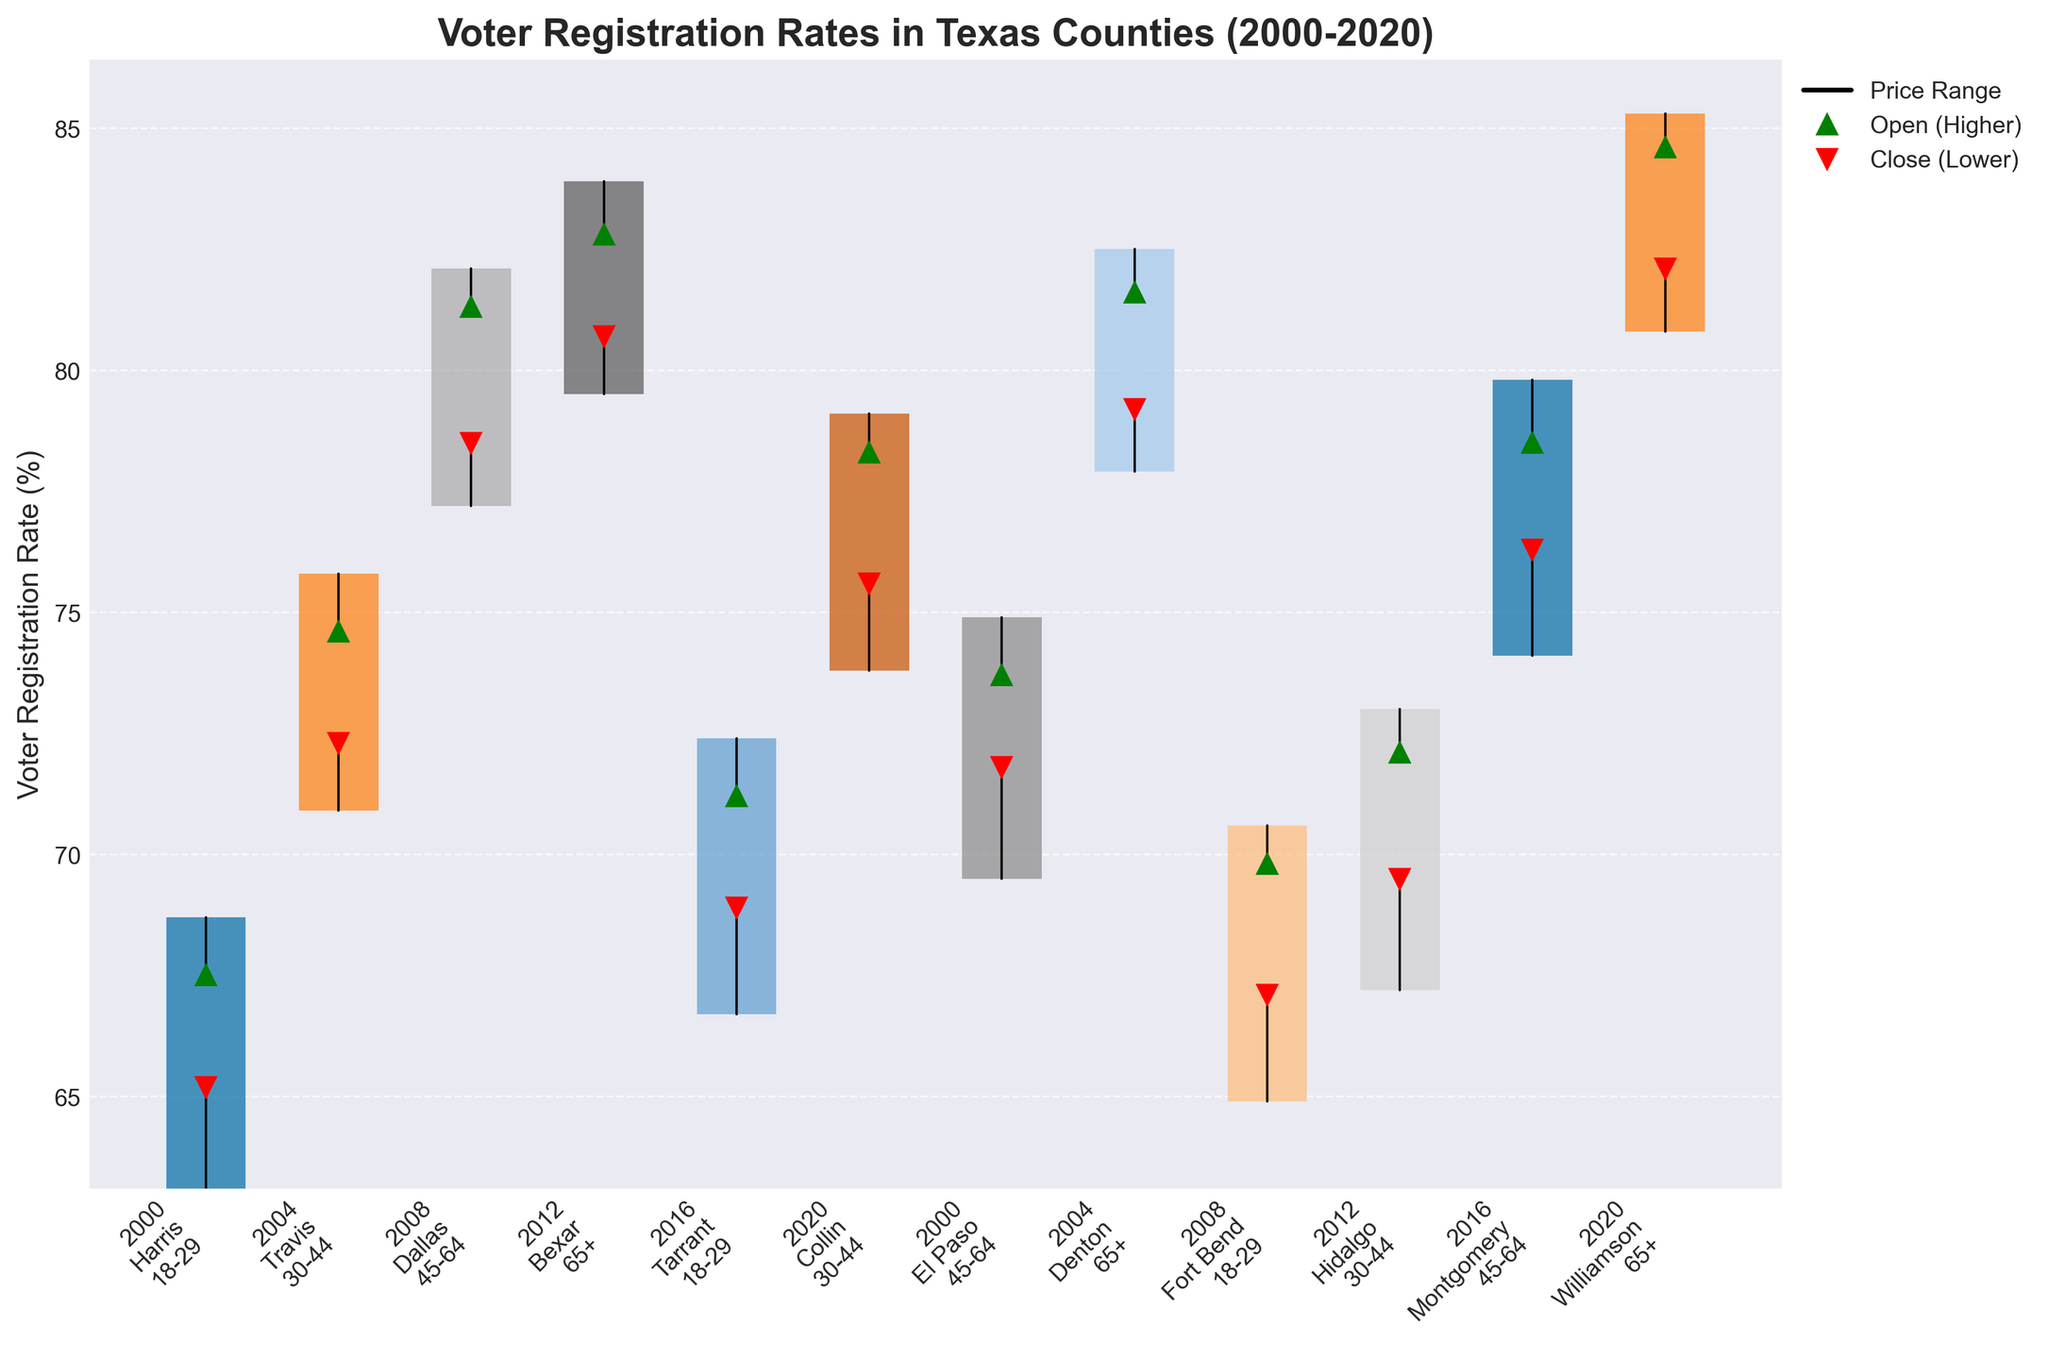What's the title of the figure? The title of the figure is prominently displayed at the top.
Answer: Voter Registration Rates in Texas Counties (2000-2020) How many distinct age groups are represented in the figure? The age groups are listed in each bar label. Counting the unique groups: "18-29", "30-44", "45-64", "65+".
Answer: 4 Which county had the highest voter registration rate in 2020 for the age group 65+? Locate the bar labeled "2020 Williamson 65+" and identify its highest value.
Answer: Williamson Which age group shows the greatest increase in voter registration rate between Open and Close values in Harris County in 2000? Examine the bar labeled "2000 Harris 18-29". The increase is the difference between Open (65.2) and Close (67.5).
Answer: 2.3% Was the voter registration rate higher at the close or open in Tarrant County in 2016 for the age group 18-29? Look for the markers on the bar labeled "2016 Tarrant 18-29". The open marker (red) is at 68.9, and the close marker (green) is at 71.2.
Answer: Close Compare the voter registration rate range (High-Low) for Dallas County in 2008 and Montgomery County in 2016 for age groups 45-64. Which one is higher? For "2008 Dallas", the range is 82.1 - 77.2 = 4.9. For "2016 Montgomery", the range is 79.8 - 74.1 = 5.7.
Answer: Montgomery County In which county and age group did the voter registration rate decrease from open to close value in 2000? Review the bars labeled "2000" and look for those where the red marker (down triangle) is above the green marker (up triangle). It's "2000 El Paso 45-64": Open=71.8, Close=73.7.
Answer: El Paso 45-64 Which county in 2012 had the highest voter registration rate at the close for the age group 65+? Check the bar labeled "2012 Bexar 65+" to find the Close value.
Answer: Bexar What is the average high voter registration rate for Travis County in 2004 and Dallas County in 2008? High values for Travis County in 2004 and Dallas County in 2008 are 75.8 and 82.1, respectively. The average is (75.8 + 82.1) / 2.
Answer: 78.95 